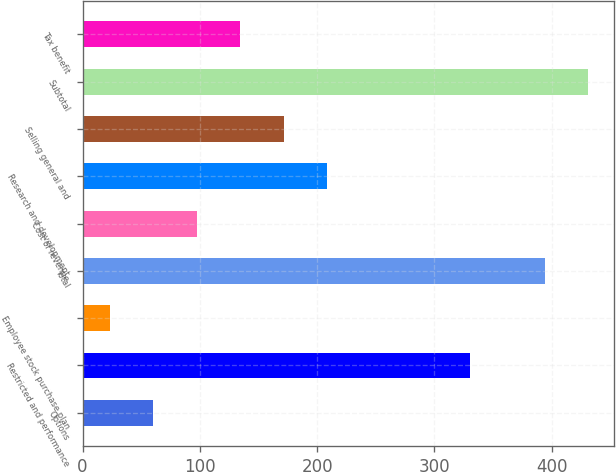<chart> <loc_0><loc_0><loc_500><loc_500><bar_chart><fcel>Options<fcel>Restricted and performance<fcel>Employee stock purchase plan<fcel>Total<fcel>Cost of revenue<fcel>Research and development<fcel>Selling general and<fcel>Subtotal<fcel>Tax benefit<nl><fcel>60.1<fcel>330<fcel>23<fcel>394<fcel>97.2<fcel>208.5<fcel>171.4<fcel>431.1<fcel>134.3<nl></chart> 